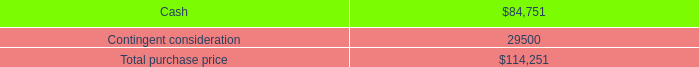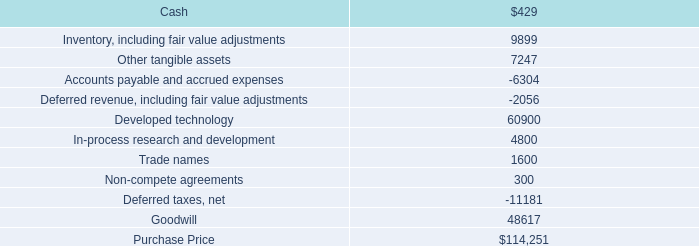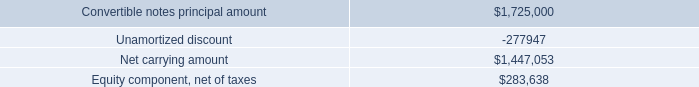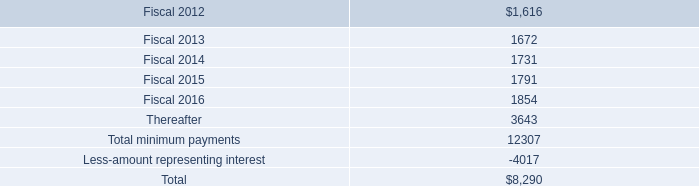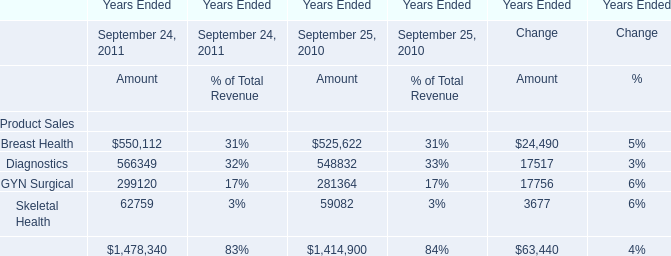What is the ratio of all Revenue for Product Sales that is smaller than 100000 to Total Revenue for Product Sales for the year ended September 25, 2010? 
Computations: (59082 / 1414900)
Answer: 0.04176. 